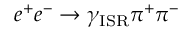<formula> <loc_0><loc_0><loc_500><loc_500>e ^ { + } e ^ { - } \to \gamma _ { I S R } \pi ^ { + } \pi ^ { - }</formula> 